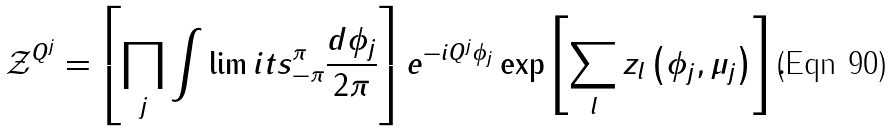<formula> <loc_0><loc_0><loc_500><loc_500>\mathcal { Z } ^ { Q ^ { j } } = \left [ \prod _ { j } \int \lim i t s _ { - \pi } ^ { \pi } \frac { d \phi _ { j } } { 2 \pi } \right ] e ^ { - i Q ^ { j } \phi _ { j } } \exp \left [ \sum _ { l } z _ { l } \left ( \phi _ { j } , \mu _ { j } \right ) \right ] .</formula> 